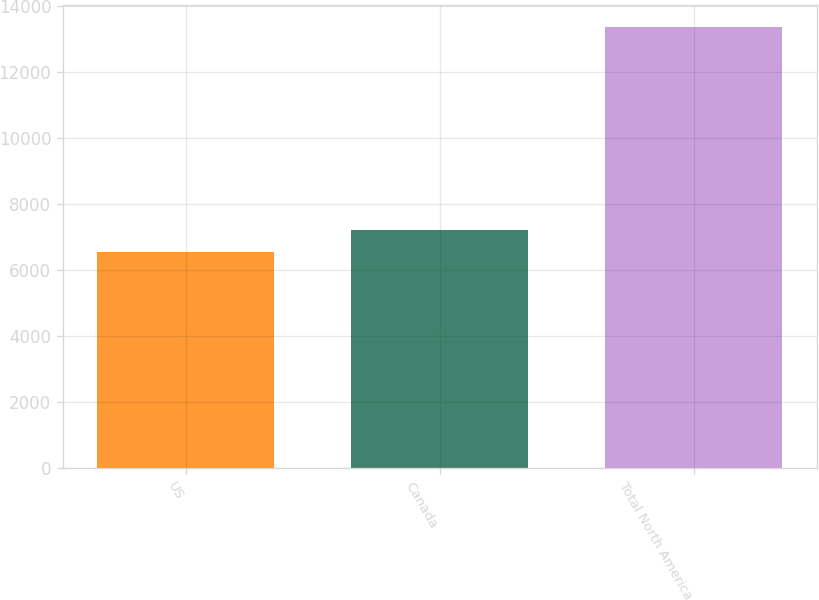Convert chart. <chart><loc_0><loc_0><loc_500><loc_500><bar_chart><fcel>US<fcel>Canada<fcel>Total North America<nl><fcel>6544<fcel>7226.7<fcel>13371<nl></chart> 